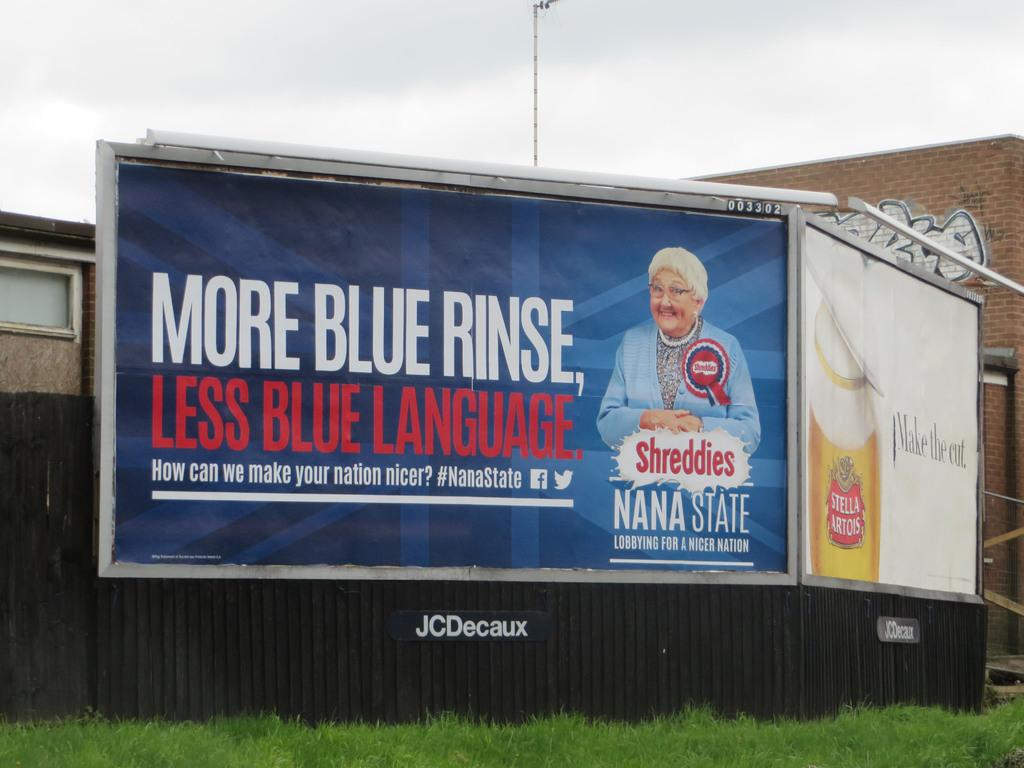<image>
Provide a brief description of the given image. A Stella Artois billboard is next to a billboard with a woman on it. 